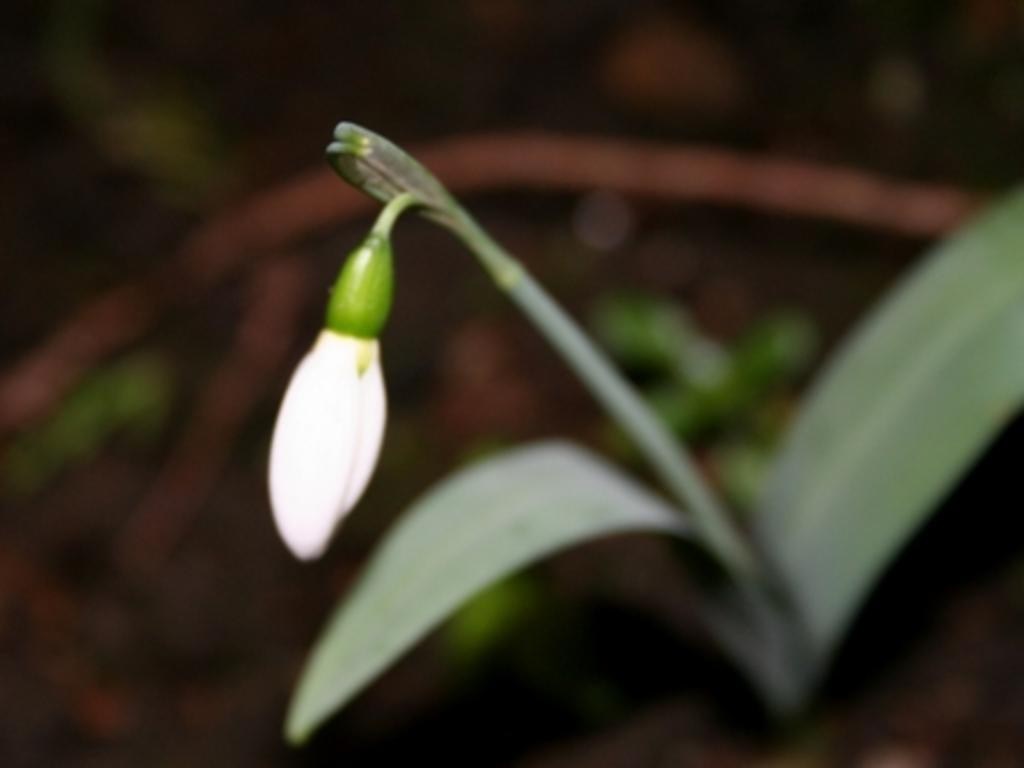What is the main subject of the image? The main subject of the image is a bud. What other parts of a plant can be seen in the image? There is a stem and leaves in the image. How would you describe the background of the image? The background of the image is blurred. Is there a rod being used to hold up the bud in the image? No, there is no rod visible in the image. The bud, stem, and leaves are likely part of a single plant, and no external support is shown. 